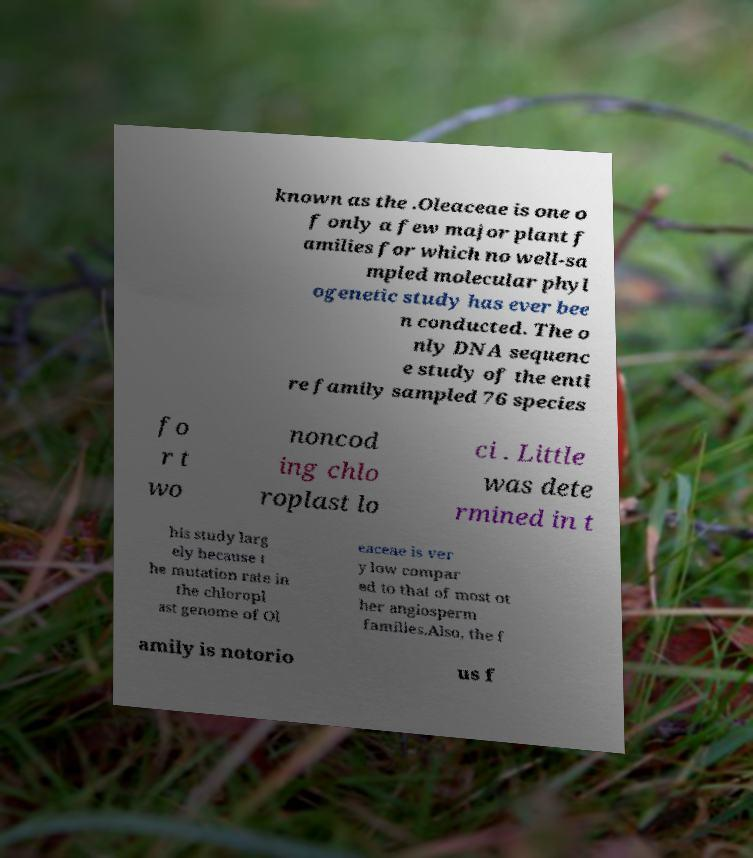There's text embedded in this image that I need extracted. Can you transcribe it verbatim? known as the .Oleaceae is one o f only a few major plant f amilies for which no well-sa mpled molecular phyl ogenetic study has ever bee n conducted. The o nly DNA sequenc e study of the enti re family sampled 76 species fo r t wo noncod ing chlo roplast lo ci . Little was dete rmined in t his study larg ely because t he mutation rate in the chloropl ast genome of Ol eaceae is ver y low compar ed to that of most ot her angiosperm families.Also, the f amily is notorio us f 